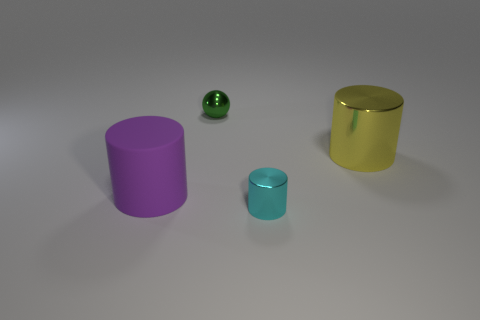Add 4 yellow matte blocks. How many objects exist? 8 Subtract all big yellow metal cylinders. How many cylinders are left? 2 Subtract all cylinders. How many objects are left? 1 Add 1 yellow metal objects. How many yellow metal objects are left? 2 Add 1 small gray matte objects. How many small gray matte objects exist? 1 Subtract all yellow cylinders. How many cylinders are left? 2 Subtract 0 yellow cubes. How many objects are left? 4 Subtract all gray cylinders. Subtract all red spheres. How many cylinders are left? 3 Subtract all yellow things. Subtract all blue matte cubes. How many objects are left? 3 